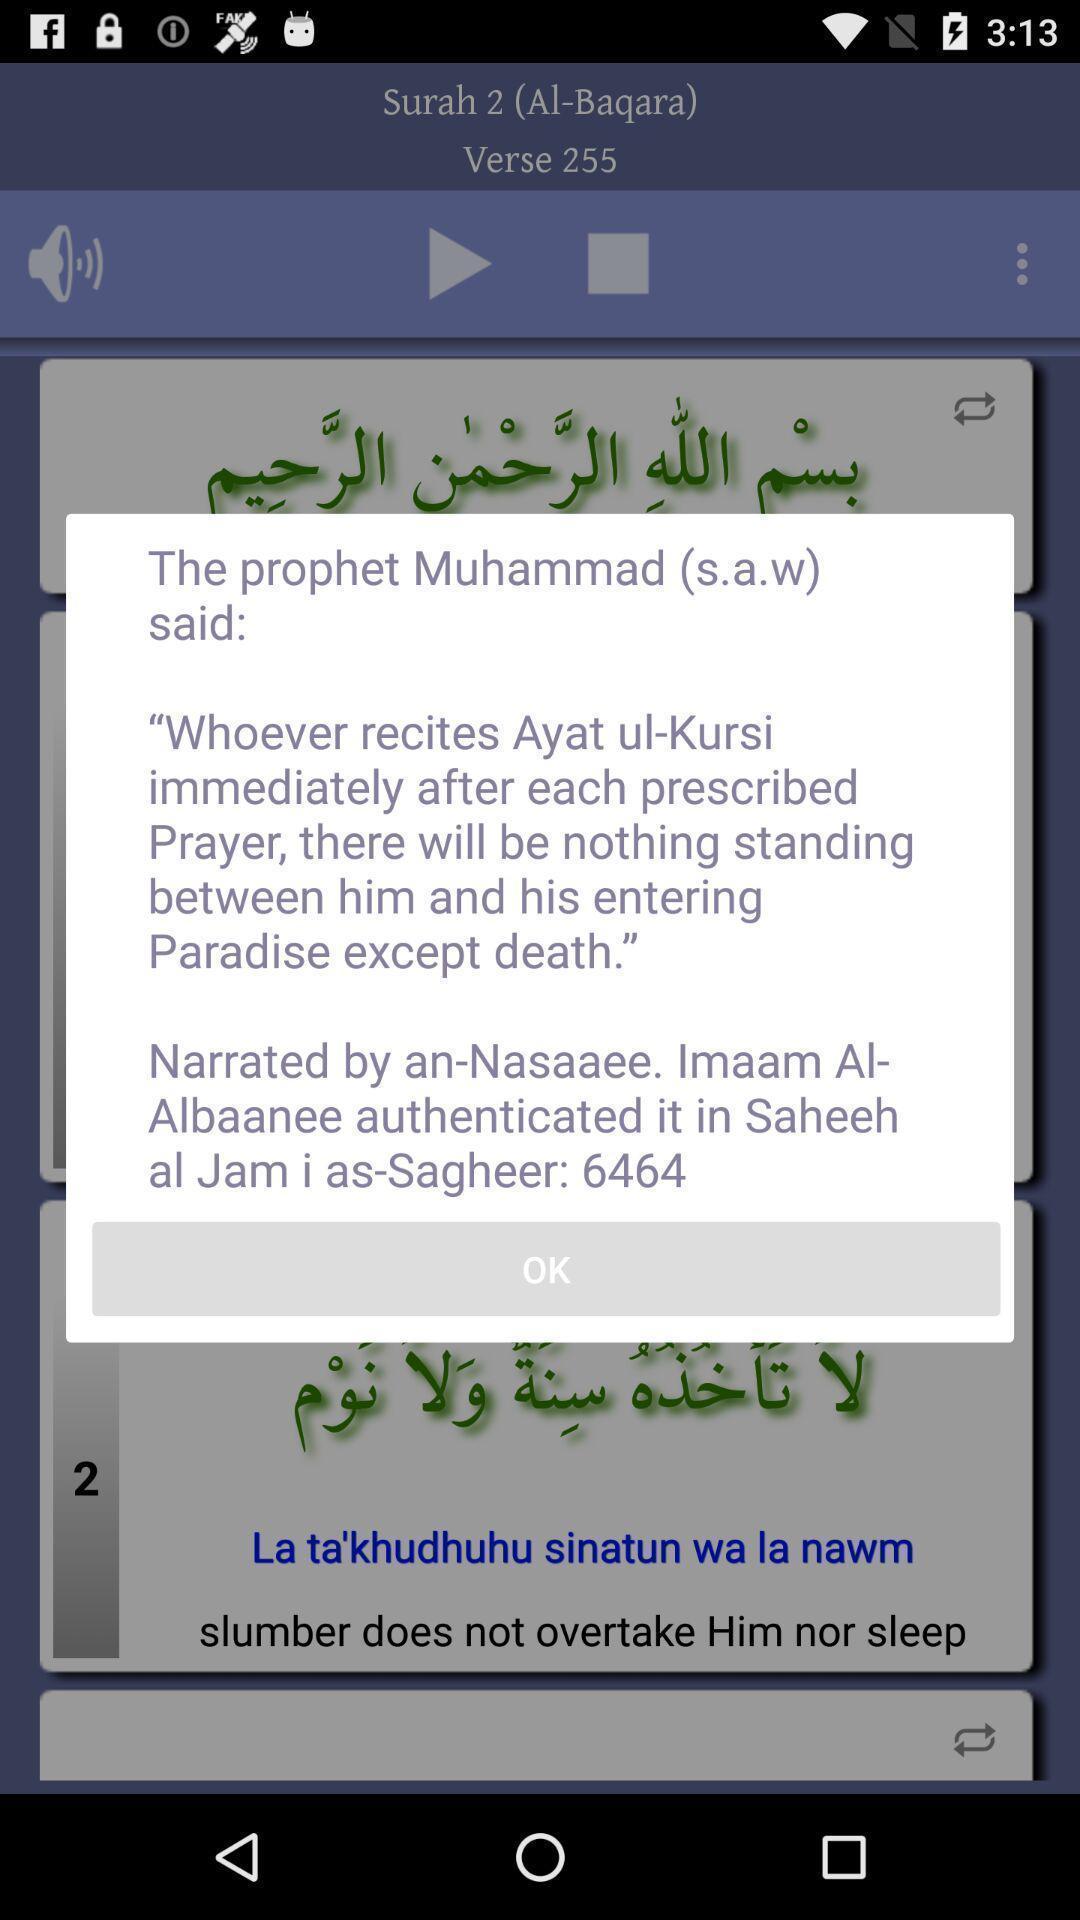What can you discern from this picture? Popup showing information about app. 